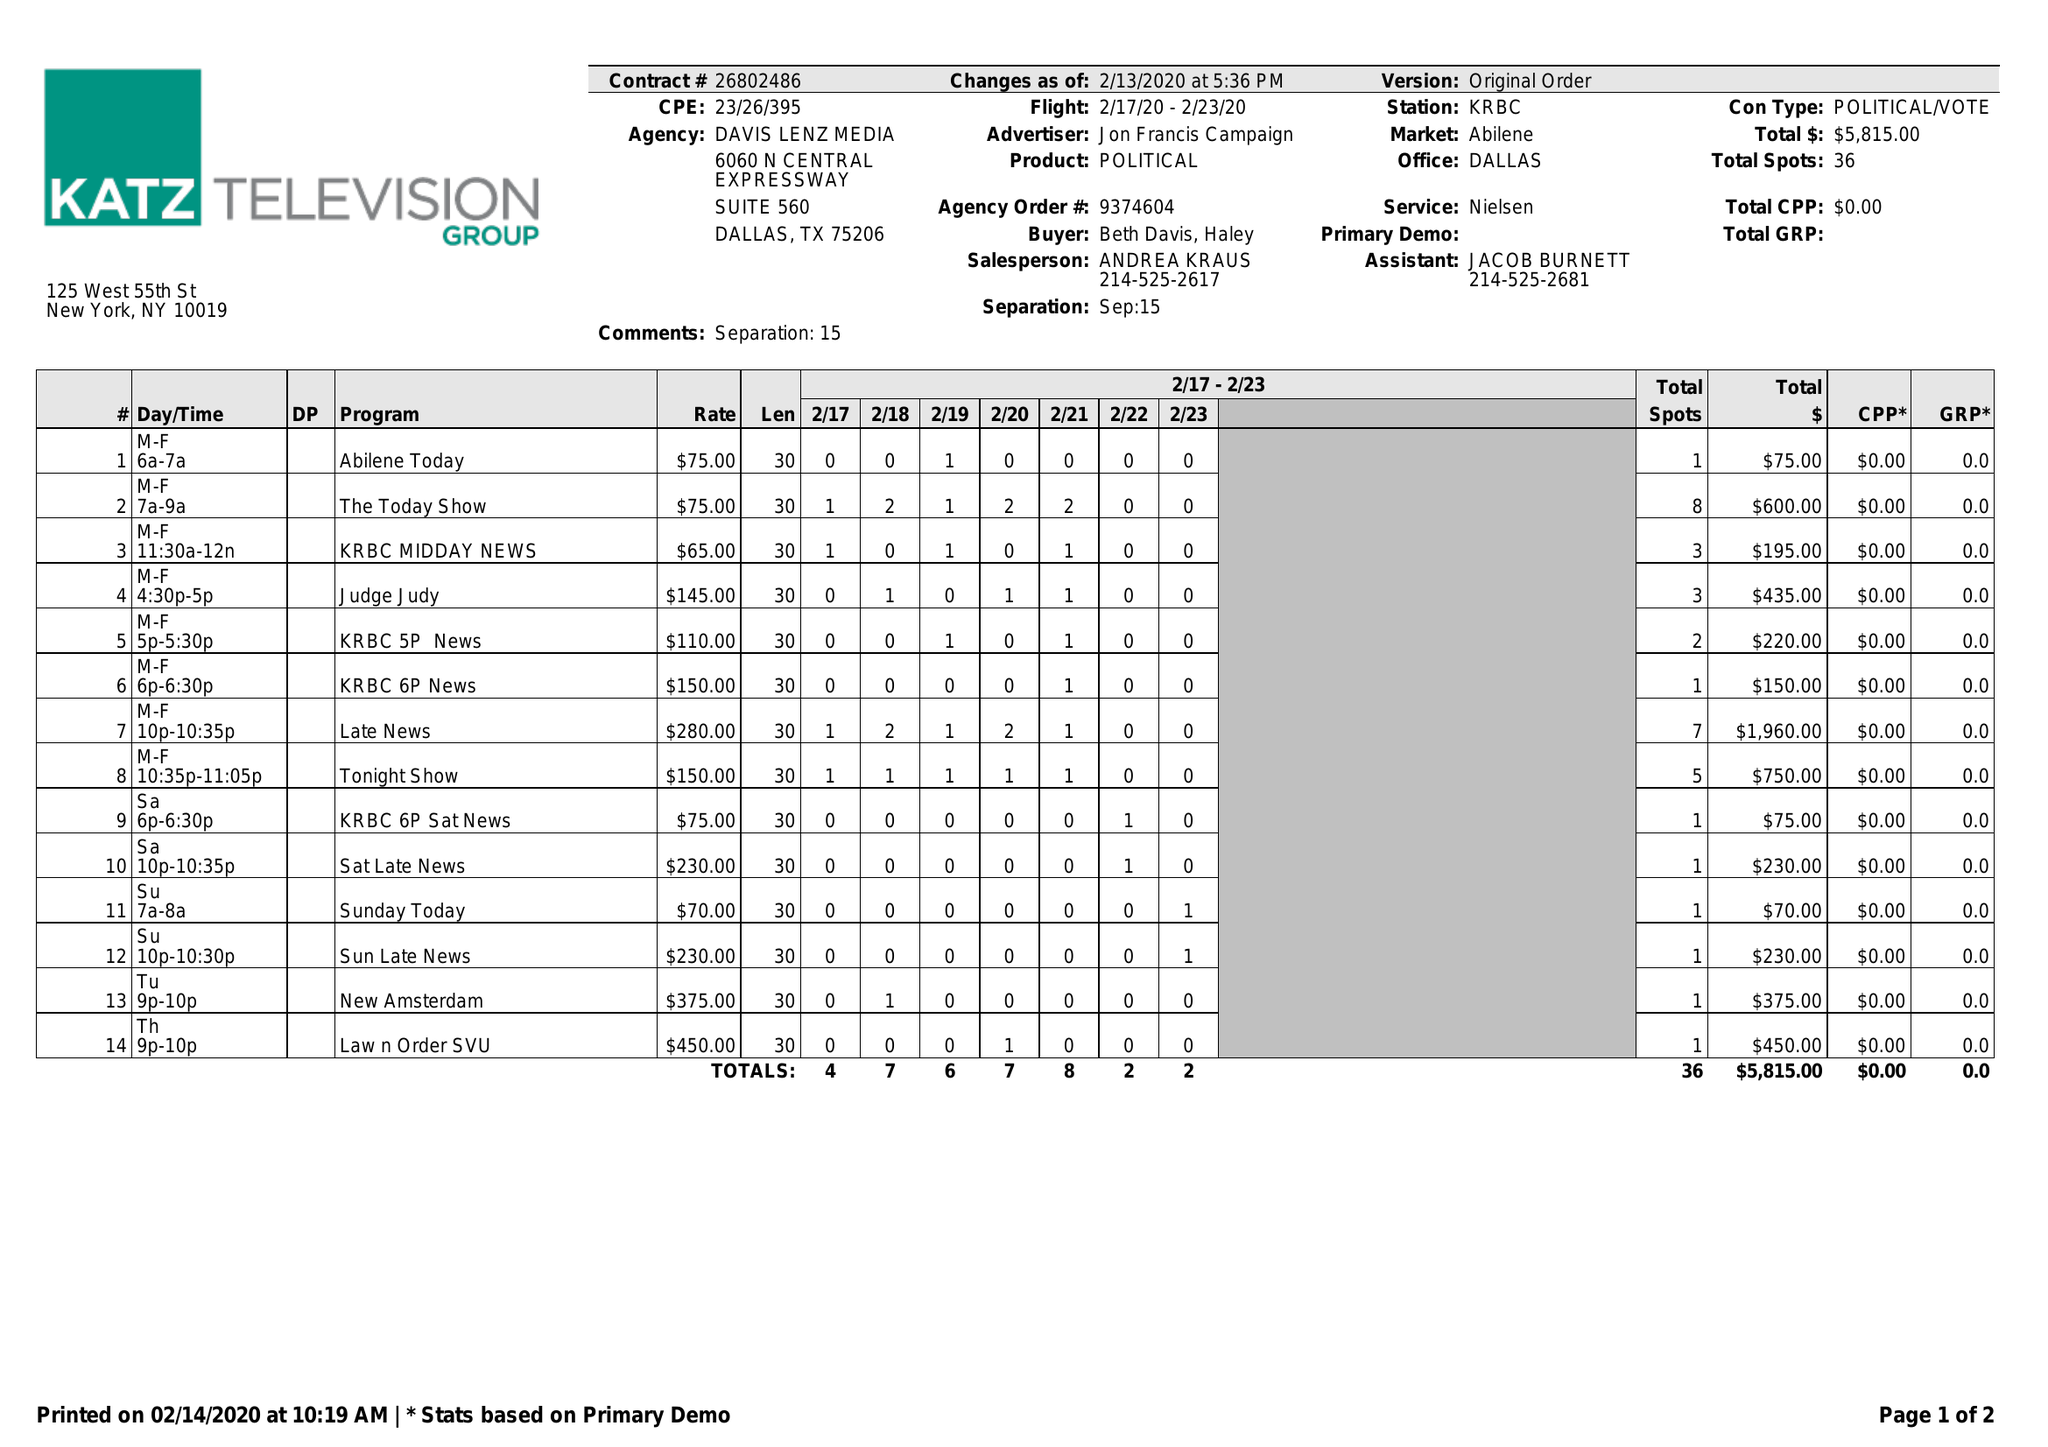What is the value for the flight_from?
Answer the question using a single word or phrase. 02/17/20 